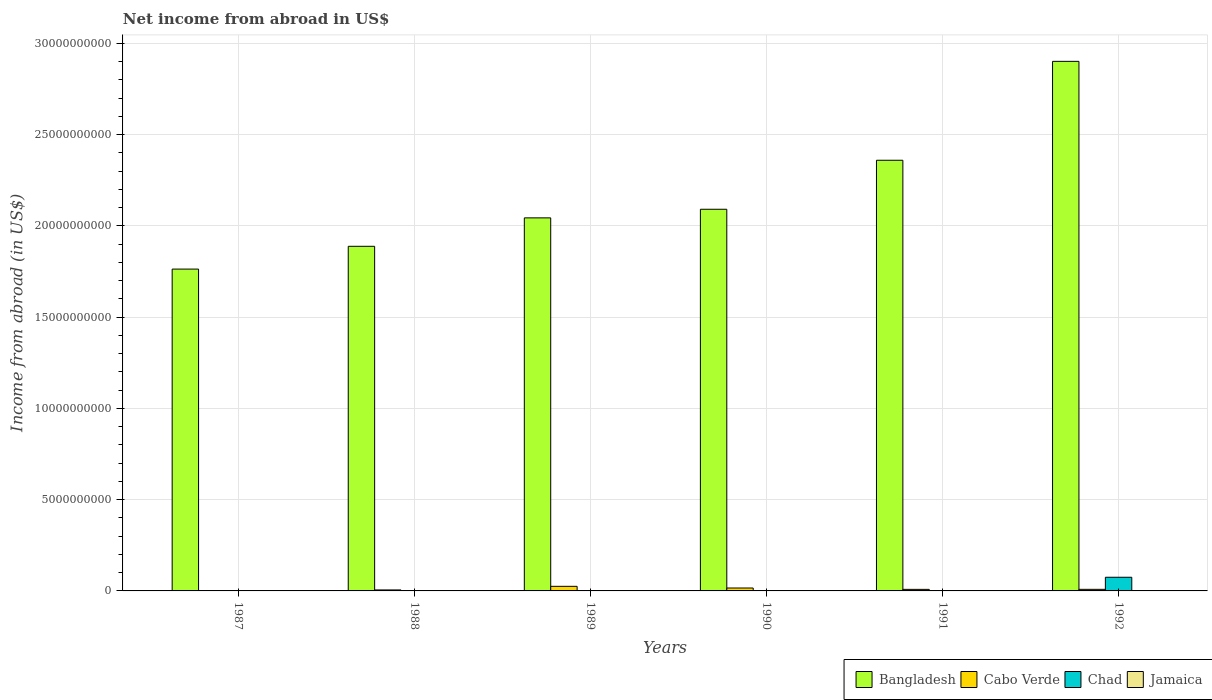How many different coloured bars are there?
Your answer should be compact. 3. Are the number of bars per tick equal to the number of legend labels?
Give a very brief answer. No. Are the number of bars on each tick of the X-axis equal?
Offer a very short reply. No. How many bars are there on the 1st tick from the right?
Your answer should be compact. 3. In how many cases, is the number of bars for a given year not equal to the number of legend labels?
Give a very brief answer. 6. Across all years, what is the maximum net income from abroad in Chad?
Keep it short and to the point. 7.49e+08. What is the difference between the net income from abroad in Bangladesh in 1987 and that in 1991?
Offer a very short reply. -5.96e+09. What is the difference between the net income from abroad in Bangladesh in 1987 and the net income from abroad in Jamaica in 1991?
Your answer should be compact. 1.76e+1. What is the average net income from abroad in Chad per year?
Keep it short and to the point. 1.25e+08. What is the ratio of the net income from abroad in Cabo Verde in 1989 to that in 1991?
Give a very brief answer. 2.94. Is the net income from abroad in Bangladesh in 1991 less than that in 1992?
Provide a short and direct response. Yes. What is the difference between the highest and the second highest net income from abroad in Bangladesh?
Ensure brevity in your answer.  5.42e+09. What is the difference between the highest and the lowest net income from abroad in Chad?
Your answer should be very brief. 7.49e+08. In how many years, is the net income from abroad in Chad greater than the average net income from abroad in Chad taken over all years?
Provide a succinct answer. 1. Is it the case that in every year, the sum of the net income from abroad in Cabo Verde and net income from abroad in Jamaica is greater than the net income from abroad in Chad?
Your answer should be compact. No. Are all the bars in the graph horizontal?
Provide a short and direct response. No. Are the values on the major ticks of Y-axis written in scientific E-notation?
Offer a very short reply. No. Does the graph contain any zero values?
Offer a terse response. Yes. How are the legend labels stacked?
Keep it short and to the point. Horizontal. What is the title of the graph?
Offer a very short reply. Net income from abroad in US$. What is the label or title of the X-axis?
Offer a terse response. Years. What is the label or title of the Y-axis?
Your answer should be very brief. Income from abroad (in US$). What is the Income from abroad (in US$) in Bangladesh in 1987?
Your answer should be very brief. 1.76e+1. What is the Income from abroad (in US$) of Jamaica in 1987?
Your answer should be compact. 0. What is the Income from abroad (in US$) in Bangladesh in 1988?
Ensure brevity in your answer.  1.89e+1. What is the Income from abroad (in US$) of Cabo Verde in 1988?
Keep it short and to the point. 5.39e+07. What is the Income from abroad (in US$) in Chad in 1988?
Make the answer very short. 0. What is the Income from abroad (in US$) of Jamaica in 1988?
Offer a terse response. 0. What is the Income from abroad (in US$) of Bangladesh in 1989?
Your answer should be very brief. 2.04e+1. What is the Income from abroad (in US$) in Cabo Verde in 1989?
Keep it short and to the point. 2.51e+08. What is the Income from abroad (in US$) in Jamaica in 1989?
Provide a succinct answer. 0. What is the Income from abroad (in US$) of Bangladesh in 1990?
Your answer should be compact. 2.09e+1. What is the Income from abroad (in US$) of Cabo Verde in 1990?
Your answer should be compact. 1.60e+08. What is the Income from abroad (in US$) in Jamaica in 1990?
Give a very brief answer. 0. What is the Income from abroad (in US$) in Bangladesh in 1991?
Your answer should be compact. 2.36e+1. What is the Income from abroad (in US$) in Cabo Verde in 1991?
Ensure brevity in your answer.  8.55e+07. What is the Income from abroad (in US$) of Bangladesh in 1992?
Make the answer very short. 2.90e+1. What is the Income from abroad (in US$) in Cabo Verde in 1992?
Make the answer very short. 8.72e+07. What is the Income from abroad (in US$) in Chad in 1992?
Provide a short and direct response. 7.49e+08. What is the Income from abroad (in US$) in Jamaica in 1992?
Make the answer very short. 0. Across all years, what is the maximum Income from abroad (in US$) of Bangladesh?
Provide a succinct answer. 2.90e+1. Across all years, what is the maximum Income from abroad (in US$) of Cabo Verde?
Give a very brief answer. 2.51e+08. Across all years, what is the maximum Income from abroad (in US$) in Chad?
Offer a very short reply. 7.49e+08. Across all years, what is the minimum Income from abroad (in US$) in Bangladesh?
Your answer should be very brief. 1.76e+1. Across all years, what is the minimum Income from abroad (in US$) in Cabo Verde?
Give a very brief answer. 0. Across all years, what is the minimum Income from abroad (in US$) of Chad?
Provide a short and direct response. 0. What is the total Income from abroad (in US$) in Bangladesh in the graph?
Your response must be concise. 1.30e+11. What is the total Income from abroad (in US$) in Cabo Verde in the graph?
Give a very brief answer. 6.38e+08. What is the total Income from abroad (in US$) in Chad in the graph?
Keep it short and to the point. 7.49e+08. What is the total Income from abroad (in US$) in Jamaica in the graph?
Offer a terse response. 0. What is the difference between the Income from abroad (in US$) of Bangladesh in 1987 and that in 1988?
Make the answer very short. -1.25e+09. What is the difference between the Income from abroad (in US$) in Bangladesh in 1987 and that in 1989?
Keep it short and to the point. -2.81e+09. What is the difference between the Income from abroad (in US$) of Bangladesh in 1987 and that in 1990?
Your answer should be compact. -3.28e+09. What is the difference between the Income from abroad (in US$) in Bangladesh in 1987 and that in 1991?
Ensure brevity in your answer.  -5.96e+09. What is the difference between the Income from abroad (in US$) in Bangladesh in 1987 and that in 1992?
Offer a terse response. -1.14e+1. What is the difference between the Income from abroad (in US$) in Bangladesh in 1988 and that in 1989?
Provide a short and direct response. -1.56e+09. What is the difference between the Income from abroad (in US$) of Cabo Verde in 1988 and that in 1989?
Your answer should be very brief. -1.97e+08. What is the difference between the Income from abroad (in US$) in Bangladesh in 1988 and that in 1990?
Make the answer very short. -2.03e+09. What is the difference between the Income from abroad (in US$) of Cabo Verde in 1988 and that in 1990?
Make the answer very short. -1.06e+08. What is the difference between the Income from abroad (in US$) of Bangladesh in 1988 and that in 1991?
Offer a terse response. -4.72e+09. What is the difference between the Income from abroad (in US$) in Cabo Verde in 1988 and that in 1991?
Offer a terse response. -3.16e+07. What is the difference between the Income from abroad (in US$) of Bangladesh in 1988 and that in 1992?
Your answer should be very brief. -1.01e+1. What is the difference between the Income from abroad (in US$) of Cabo Verde in 1988 and that in 1992?
Provide a succinct answer. -3.32e+07. What is the difference between the Income from abroad (in US$) in Bangladesh in 1989 and that in 1990?
Give a very brief answer. -4.72e+08. What is the difference between the Income from abroad (in US$) in Cabo Verde in 1989 and that in 1990?
Provide a short and direct response. 9.11e+07. What is the difference between the Income from abroad (in US$) of Bangladesh in 1989 and that in 1991?
Offer a very short reply. -3.16e+09. What is the difference between the Income from abroad (in US$) in Cabo Verde in 1989 and that in 1991?
Offer a very short reply. 1.66e+08. What is the difference between the Income from abroad (in US$) in Bangladesh in 1989 and that in 1992?
Provide a succinct answer. -8.58e+09. What is the difference between the Income from abroad (in US$) of Cabo Verde in 1989 and that in 1992?
Offer a very short reply. 1.64e+08. What is the difference between the Income from abroad (in US$) in Bangladesh in 1990 and that in 1991?
Offer a very short reply. -2.68e+09. What is the difference between the Income from abroad (in US$) in Cabo Verde in 1990 and that in 1991?
Ensure brevity in your answer.  7.45e+07. What is the difference between the Income from abroad (in US$) in Bangladesh in 1990 and that in 1992?
Provide a short and direct response. -8.10e+09. What is the difference between the Income from abroad (in US$) in Cabo Verde in 1990 and that in 1992?
Your answer should be compact. 7.29e+07. What is the difference between the Income from abroad (in US$) of Bangladesh in 1991 and that in 1992?
Keep it short and to the point. -5.42e+09. What is the difference between the Income from abroad (in US$) in Cabo Verde in 1991 and that in 1992?
Your answer should be compact. -1.66e+06. What is the difference between the Income from abroad (in US$) in Bangladesh in 1987 and the Income from abroad (in US$) in Cabo Verde in 1988?
Make the answer very short. 1.76e+1. What is the difference between the Income from abroad (in US$) of Bangladesh in 1987 and the Income from abroad (in US$) of Cabo Verde in 1989?
Offer a very short reply. 1.74e+1. What is the difference between the Income from abroad (in US$) in Bangladesh in 1987 and the Income from abroad (in US$) in Cabo Verde in 1990?
Keep it short and to the point. 1.75e+1. What is the difference between the Income from abroad (in US$) in Bangladesh in 1987 and the Income from abroad (in US$) in Cabo Verde in 1991?
Your answer should be very brief. 1.76e+1. What is the difference between the Income from abroad (in US$) of Bangladesh in 1987 and the Income from abroad (in US$) of Cabo Verde in 1992?
Ensure brevity in your answer.  1.75e+1. What is the difference between the Income from abroad (in US$) of Bangladesh in 1987 and the Income from abroad (in US$) of Chad in 1992?
Ensure brevity in your answer.  1.69e+1. What is the difference between the Income from abroad (in US$) of Bangladesh in 1988 and the Income from abroad (in US$) of Cabo Verde in 1989?
Your response must be concise. 1.86e+1. What is the difference between the Income from abroad (in US$) in Bangladesh in 1988 and the Income from abroad (in US$) in Cabo Verde in 1990?
Make the answer very short. 1.87e+1. What is the difference between the Income from abroad (in US$) of Bangladesh in 1988 and the Income from abroad (in US$) of Cabo Verde in 1991?
Give a very brief answer. 1.88e+1. What is the difference between the Income from abroad (in US$) of Bangladesh in 1988 and the Income from abroad (in US$) of Cabo Verde in 1992?
Ensure brevity in your answer.  1.88e+1. What is the difference between the Income from abroad (in US$) of Bangladesh in 1988 and the Income from abroad (in US$) of Chad in 1992?
Provide a short and direct response. 1.81e+1. What is the difference between the Income from abroad (in US$) in Cabo Verde in 1988 and the Income from abroad (in US$) in Chad in 1992?
Give a very brief answer. -6.95e+08. What is the difference between the Income from abroad (in US$) of Bangladesh in 1989 and the Income from abroad (in US$) of Cabo Verde in 1990?
Ensure brevity in your answer.  2.03e+1. What is the difference between the Income from abroad (in US$) in Bangladesh in 1989 and the Income from abroad (in US$) in Cabo Verde in 1991?
Your answer should be compact. 2.04e+1. What is the difference between the Income from abroad (in US$) in Bangladesh in 1989 and the Income from abroad (in US$) in Cabo Verde in 1992?
Provide a succinct answer. 2.04e+1. What is the difference between the Income from abroad (in US$) of Bangladesh in 1989 and the Income from abroad (in US$) of Chad in 1992?
Ensure brevity in your answer.  1.97e+1. What is the difference between the Income from abroad (in US$) in Cabo Verde in 1989 and the Income from abroad (in US$) in Chad in 1992?
Provide a short and direct response. -4.98e+08. What is the difference between the Income from abroad (in US$) of Bangladesh in 1990 and the Income from abroad (in US$) of Cabo Verde in 1991?
Provide a short and direct response. 2.08e+1. What is the difference between the Income from abroad (in US$) in Bangladesh in 1990 and the Income from abroad (in US$) in Cabo Verde in 1992?
Make the answer very short. 2.08e+1. What is the difference between the Income from abroad (in US$) in Bangladesh in 1990 and the Income from abroad (in US$) in Chad in 1992?
Provide a succinct answer. 2.02e+1. What is the difference between the Income from abroad (in US$) in Cabo Verde in 1990 and the Income from abroad (in US$) in Chad in 1992?
Your answer should be very brief. -5.89e+08. What is the difference between the Income from abroad (in US$) of Bangladesh in 1991 and the Income from abroad (in US$) of Cabo Verde in 1992?
Ensure brevity in your answer.  2.35e+1. What is the difference between the Income from abroad (in US$) in Bangladesh in 1991 and the Income from abroad (in US$) in Chad in 1992?
Give a very brief answer. 2.29e+1. What is the difference between the Income from abroad (in US$) in Cabo Verde in 1991 and the Income from abroad (in US$) in Chad in 1992?
Your answer should be very brief. -6.63e+08. What is the average Income from abroad (in US$) in Bangladesh per year?
Ensure brevity in your answer.  2.17e+1. What is the average Income from abroad (in US$) in Cabo Verde per year?
Your response must be concise. 1.06e+08. What is the average Income from abroad (in US$) in Chad per year?
Offer a terse response. 1.25e+08. What is the average Income from abroad (in US$) of Jamaica per year?
Give a very brief answer. 0. In the year 1988, what is the difference between the Income from abroad (in US$) of Bangladesh and Income from abroad (in US$) of Cabo Verde?
Offer a very short reply. 1.88e+1. In the year 1989, what is the difference between the Income from abroad (in US$) of Bangladesh and Income from abroad (in US$) of Cabo Verde?
Give a very brief answer. 2.02e+1. In the year 1990, what is the difference between the Income from abroad (in US$) in Bangladesh and Income from abroad (in US$) in Cabo Verde?
Give a very brief answer. 2.08e+1. In the year 1991, what is the difference between the Income from abroad (in US$) in Bangladesh and Income from abroad (in US$) in Cabo Verde?
Your response must be concise. 2.35e+1. In the year 1992, what is the difference between the Income from abroad (in US$) of Bangladesh and Income from abroad (in US$) of Cabo Verde?
Provide a succinct answer. 2.89e+1. In the year 1992, what is the difference between the Income from abroad (in US$) of Bangladesh and Income from abroad (in US$) of Chad?
Give a very brief answer. 2.83e+1. In the year 1992, what is the difference between the Income from abroad (in US$) in Cabo Verde and Income from abroad (in US$) in Chad?
Offer a terse response. -6.62e+08. What is the ratio of the Income from abroad (in US$) of Bangladesh in 1987 to that in 1988?
Offer a very short reply. 0.93. What is the ratio of the Income from abroad (in US$) in Bangladesh in 1987 to that in 1989?
Your answer should be very brief. 0.86. What is the ratio of the Income from abroad (in US$) in Bangladesh in 1987 to that in 1990?
Your response must be concise. 0.84. What is the ratio of the Income from abroad (in US$) of Bangladesh in 1987 to that in 1991?
Your answer should be very brief. 0.75. What is the ratio of the Income from abroad (in US$) of Bangladesh in 1987 to that in 1992?
Provide a short and direct response. 0.61. What is the ratio of the Income from abroad (in US$) of Bangladesh in 1988 to that in 1989?
Provide a succinct answer. 0.92. What is the ratio of the Income from abroad (in US$) in Cabo Verde in 1988 to that in 1989?
Make the answer very short. 0.21. What is the ratio of the Income from abroad (in US$) of Bangladesh in 1988 to that in 1990?
Provide a succinct answer. 0.9. What is the ratio of the Income from abroad (in US$) in Cabo Verde in 1988 to that in 1990?
Provide a short and direct response. 0.34. What is the ratio of the Income from abroad (in US$) in Bangladesh in 1988 to that in 1991?
Your answer should be compact. 0.8. What is the ratio of the Income from abroad (in US$) of Cabo Verde in 1988 to that in 1991?
Provide a short and direct response. 0.63. What is the ratio of the Income from abroad (in US$) of Bangladesh in 1988 to that in 1992?
Make the answer very short. 0.65. What is the ratio of the Income from abroad (in US$) of Cabo Verde in 1988 to that in 1992?
Your answer should be compact. 0.62. What is the ratio of the Income from abroad (in US$) of Bangladesh in 1989 to that in 1990?
Offer a very short reply. 0.98. What is the ratio of the Income from abroad (in US$) in Cabo Verde in 1989 to that in 1990?
Make the answer very short. 1.57. What is the ratio of the Income from abroad (in US$) in Bangladesh in 1989 to that in 1991?
Your response must be concise. 0.87. What is the ratio of the Income from abroad (in US$) of Cabo Verde in 1989 to that in 1991?
Make the answer very short. 2.94. What is the ratio of the Income from abroad (in US$) of Bangladesh in 1989 to that in 1992?
Offer a very short reply. 0.7. What is the ratio of the Income from abroad (in US$) in Cabo Verde in 1989 to that in 1992?
Provide a short and direct response. 2.88. What is the ratio of the Income from abroad (in US$) of Bangladesh in 1990 to that in 1991?
Provide a short and direct response. 0.89. What is the ratio of the Income from abroad (in US$) of Cabo Verde in 1990 to that in 1991?
Provide a short and direct response. 1.87. What is the ratio of the Income from abroad (in US$) in Bangladesh in 1990 to that in 1992?
Make the answer very short. 0.72. What is the ratio of the Income from abroad (in US$) in Cabo Verde in 1990 to that in 1992?
Make the answer very short. 1.84. What is the ratio of the Income from abroad (in US$) of Bangladesh in 1991 to that in 1992?
Provide a short and direct response. 0.81. What is the ratio of the Income from abroad (in US$) of Cabo Verde in 1991 to that in 1992?
Provide a succinct answer. 0.98. What is the difference between the highest and the second highest Income from abroad (in US$) of Bangladesh?
Provide a short and direct response. 5.42e+09. What is the difference between the highest and the second highest Income from abroad (in US$) in Cabo Verde?
Offer a very short reply. 9.11e+07. What is the difference between the highest and the lowest Income from abroad (in US$) in Bangladesh?
Give a very brief answer. 1.14e+1. What is the difference between the highest and the lowest Income from abroad (in US$) in Cabo Verde?
Provide a short and direct response. 2.51e+08. What is the difference between the highest and the lowest Income from abroad (in US$) of Chad?
Your answer should be very brief. 7.49e+08. 